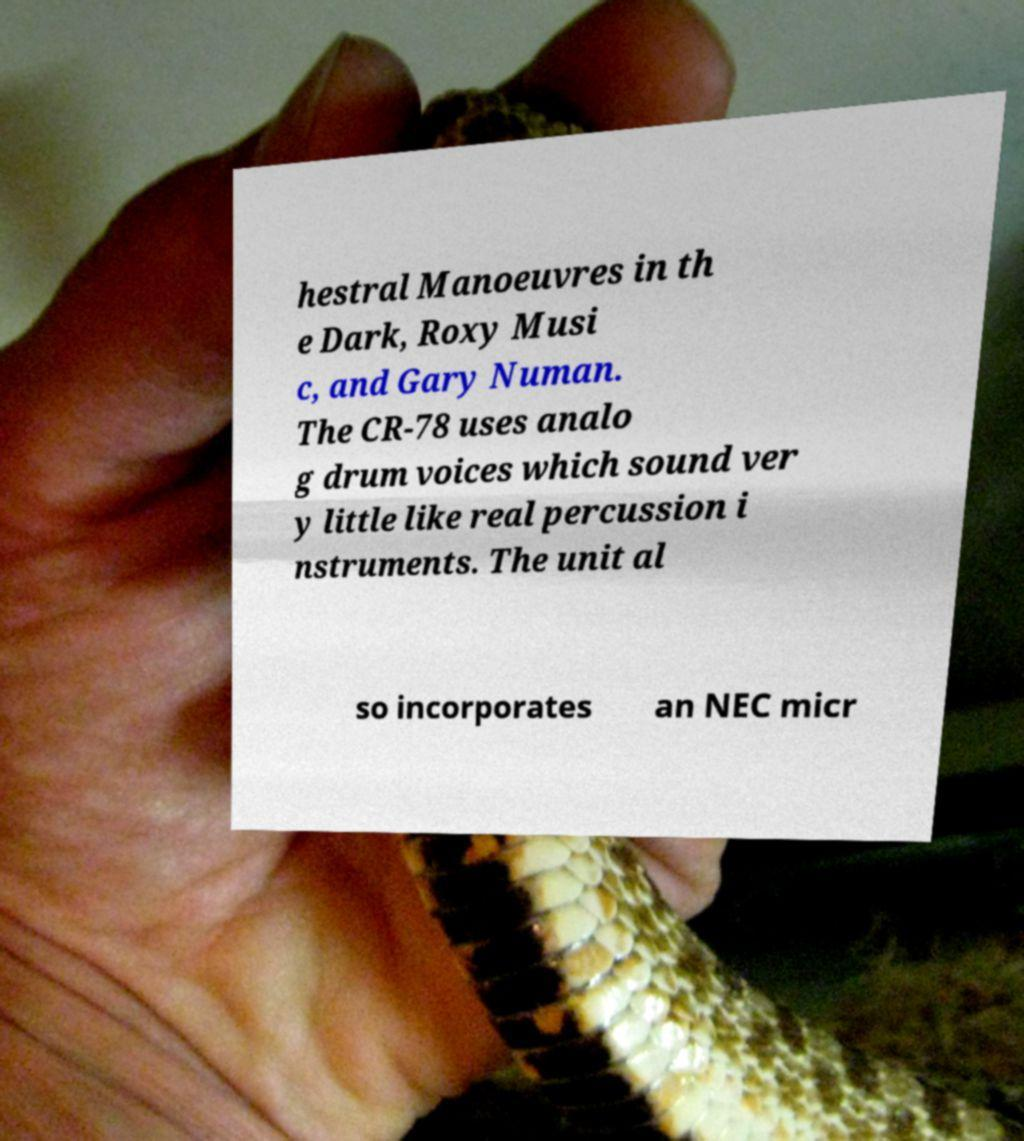Can you read and provide the text displayed in the image?This photo seems to have some interesting text. Can you extract and type it out for me? hestral Manoeuvres in th e Dark, Roxy Musi c, and Gary Numan. The CR-78 uses analo g drum voices which sound ver y little like real percussion i nstruments. The unit al so incorporates an NEC micr 